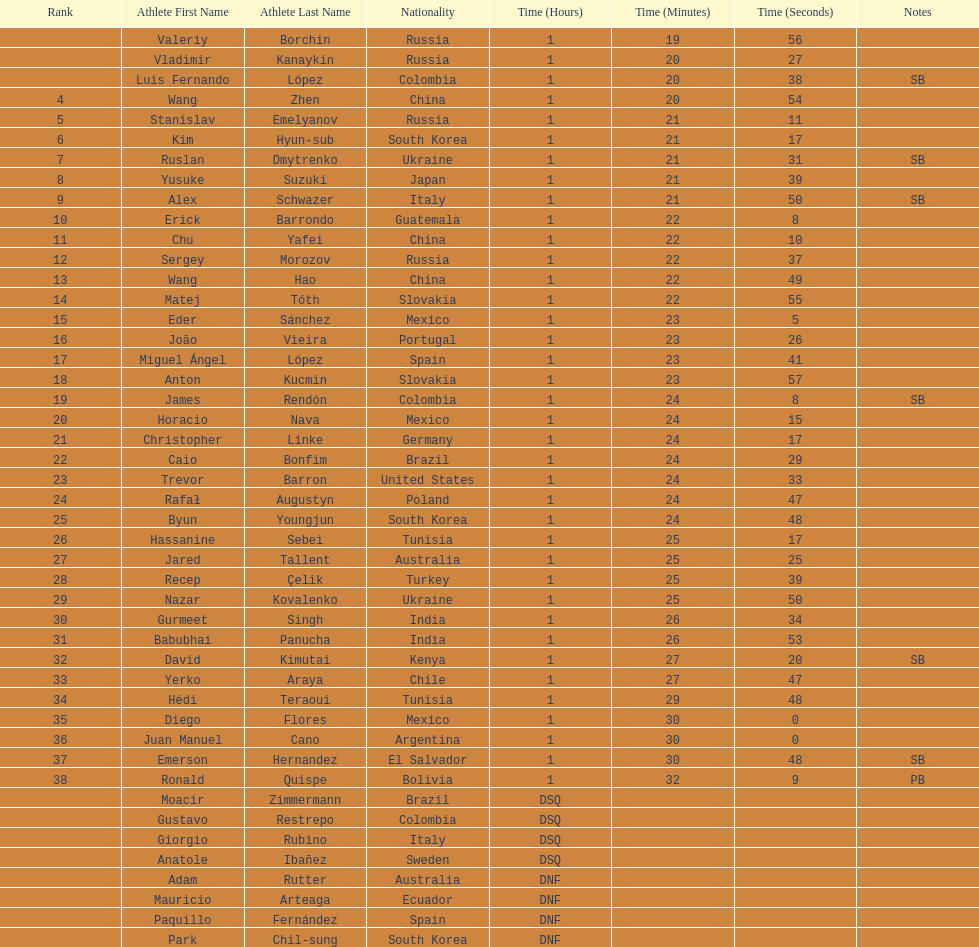Which competitor was ranked first? Valeriy Borchin. 